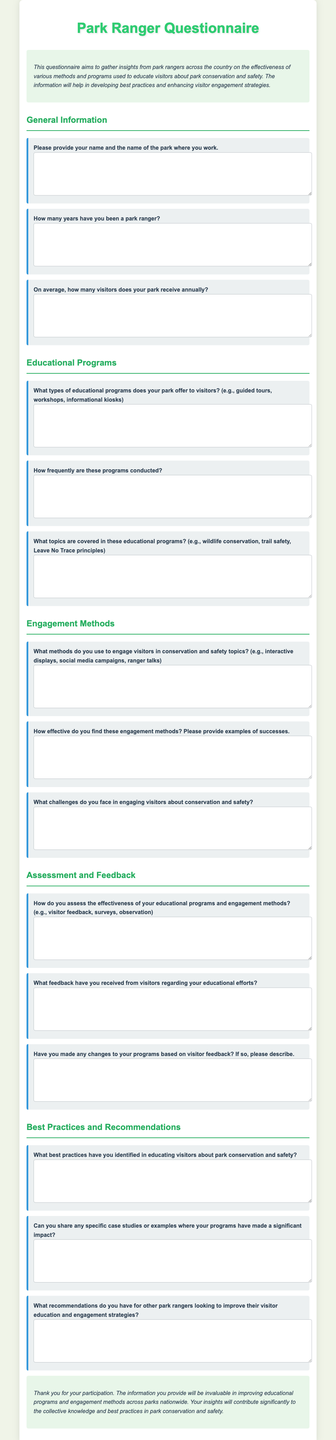what is the title of the document? The title is found in the <title> tag of the HTML document.
Answer: Park Ranger Questionnaire what is the purpose of the questionnaire? The purpose is stated in the introduction section as gathering insights from park rangers.
Answer: To gather insights how many sections are in the document? The sections are indicated by the <h2> tags, which show distinct topics covered.
Answer: 4 what types of educational programs are mentioned? The types of programs are asked in a specific question within the Educational Programs section.
Answer: Guided tours, workshops, informational kiosks what challenges are park rangers asking about in visitor engagement? The question addresses the difficulties rangers face, found in the Engagement Methods section.
Answer: Challenges in engaging visitors how is the effectiveness of educational programs assessed? The methods of assessment are mentioned in relation to the feedback gathered from visitors.
Answer: Visitor feedback, surveys, observation what best practices have been identified for educating visitors? The question seeks specific insights from the respondents in the Best Practices and Recommendations section.
Answer: Best practices in educating visitors what type of feedback is mentioned regarding educational efforts? The inquiry relates to visitor responses and opinions shared with rangers, found in the Assessment and Feedback section.
Answer: Feedback from visitors what is the significance of the information collected from the questionnaire? The conclusion section mentions the overall value of the responses gathered from participants.
Answer: Improving educational programs and engagement methods 